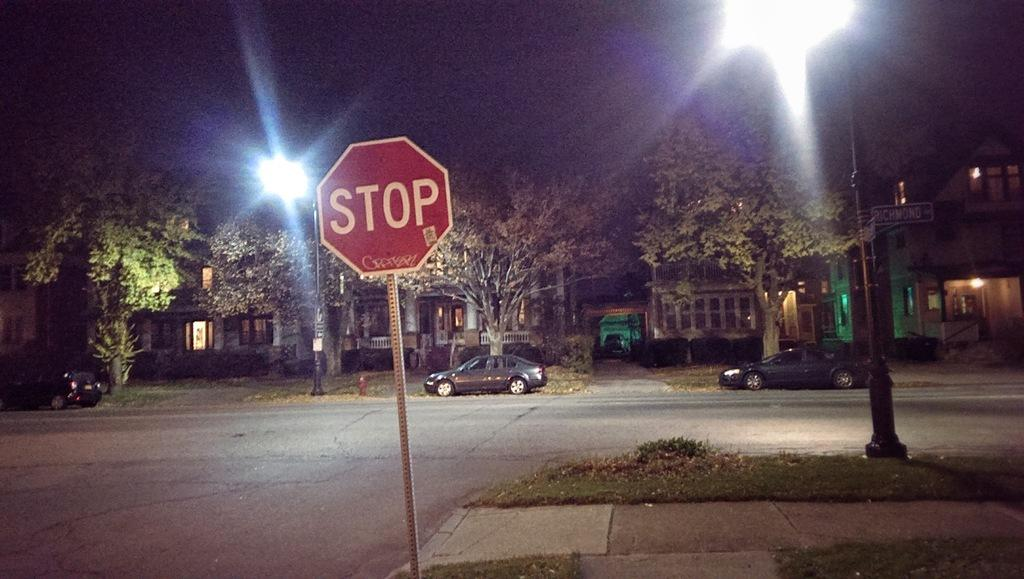<image>
Describe the image concisely. A city intersection at night has a red sign that says Stop. 